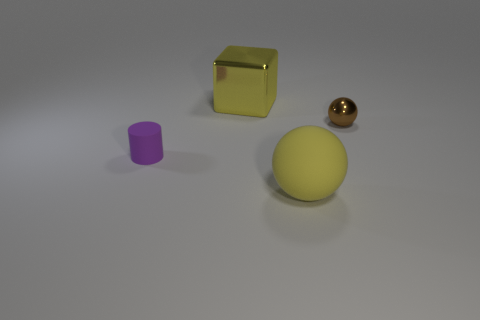Add 4 matte balls. How many objects exist? 8 Subtract all cubes. How many objects are left? 3 Subtract all gray balls. Subtract all gray blocks. How many balls are left? 2 Subtract all tiny brown shiny balls. Subtract all rubber cylinders. How many objects are left? 2 Add 3 small purple rubber things. How many small purple rubber things are left? 4 Add 2 tiny metal objects. How many tiny metal objects exist? 3 Subtract 0 brown cubes. How many objects are left? 4 